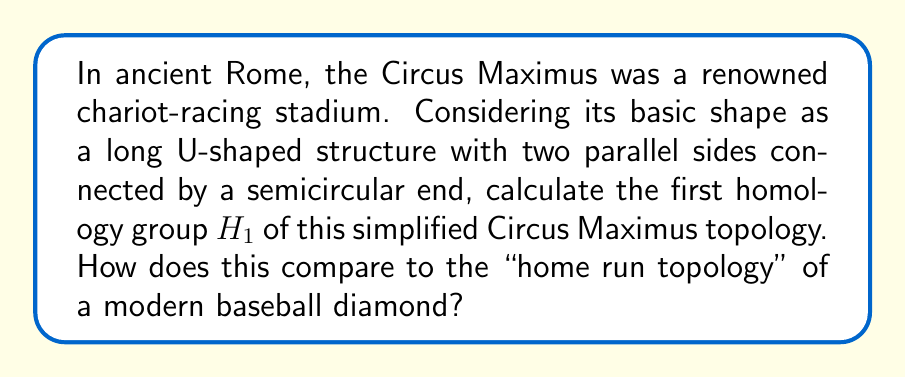Provide a solution to this math problem. To solve this problem, we'll follow these steps:

1) First, let's consider the simplified topology of the Circus Maximus:
   [asy]
   size(200);
   path p = (0,0)--(100,0)--arc((100,50),50,270,90)--(0,100)--cycle;
   draw(p);
   label("Circus Maximus", (50,50));
   [/asy]

2) This shape is homotopy equivalent to a circle. To see this, we can continuously deform the long sides towards each other until they meet, resulting in a circular shape.

3) For a circle, we know that:
   $$H_0(S^1) \cong \mathbb{Z}$$
   $$H_1(S^1) \cong \mathbb{Z}$$
   $$H_n(S^1) \cong 0 \text{ for } n \geq 2$$

4) Therefore, the first homology group of the Circus Maximus topology is:
   $$H_1(\text{Circus Maximus}) \cong \mathbb{Z}$$

5) Now, let's compare this to a modern baseball diamond:
   [asy]
   size(200);
   path p = (0,0)--(100,0)--(100,100)--(0,100)--cycle;
   draw(p);
   label("Baseball Diamond", (50,50));
   [/asy]

6) The baseball diamond is topologically equivalent to a square, which is contractible to a point. Its homology groups are:
   $$H_0(\text{Baseball Diamond}) \cong \mathbb{Z}$$
   $$H_n(\text{Baseball Diamond}) \cong 0 \text{ for } n \geq 1$$

7) The "home run topology" would consider the path of a home run ball, which forms a loop around the diamond. This loop is not contractible within the playing field, making the topology more similar to that of the Circus Maximus.

8) Therefore, the "home run topology" of a baseball diamond would have the same first homology group as the Circus Maximus:
   $$H_1(\text{Home Run Topology}) \cong \mathbb{Z}$$

This comparison shows that while the basic shape of a baseball field differs from the Circus Maximus, the topology created by the path of a home run is similar to the ancient Roman stadium from a homological perspective.
Answer: The first homology group of the simplified Circus Maximus topology is $H_1(\text{Circus Maximus}) \cong \mathbb{Z}$. This is the same as the "home run topology" of a modern baseball diamond, $H_1(\text{Home Run Topology}) \cong \mathbb{Z}$, despite the different basic shapes of the structures. 